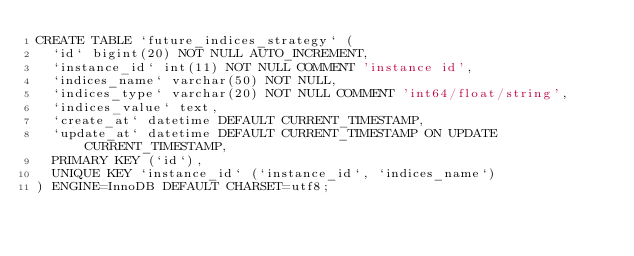<code> <loc_0><loc_0><loc_500><loc_500><_SQL_>CREATE TABLE `future_indices_strategy` (
  `id` bigint(20) NOT NULL AUTO_INCREMENT,
  `instance_id` int(11) NOT NULL COMMENT 'instance id',
  `indices_name` varchar(50) NOT NULL,
  `indices_type` varchar(20) NOT NULL COMMENT 'int64/float/string',
  `indices_value` text,
  `create_at` datetime DEFAULT CURRENT_TIMESTAMP,
  `update_at` datetime DEFAULT CURRENT_TIMESTAMP ON UPDATE CURRENT_TIMESTAMP,
  PRIMARY KEY (`id`),
  UNIQUE KEY `instance_id` (`instance_id`, `indices_name`)
) ENGINE=InnoDB DEFAULT CHARSET=utf8;
</code> 